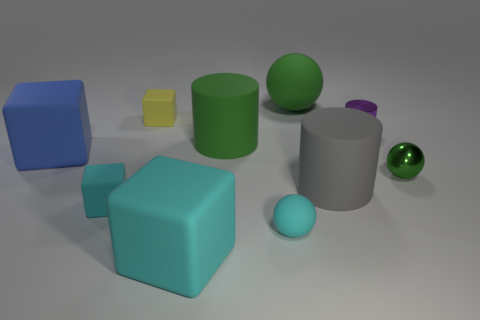Are there more cubes that are right of the big blue cube than large blue cubes that are behind the small yellow rubber thing?
Your response must be concise. Yes. There is a big object that is behind the small shiny cylinder; is it the same color as the big rubber cylinder behind the big gray rubber cylinder?
Keep it short and to the point. Yes. What is the size of the ball in front of the green sphere to the right of the large green matte object behind the tiny purple object?
Give a very brief answer. Small. What is the color of the shiny thing that is the same shape as the gray matte thing?
Offer a terse response. Purple. Is the number of green metal balls that are behind the cyan rubber ball greater than the number of purple rubber cylinders?
Give a very brief answer. Yes. Does the blue object have the same shape as the tiny matte object behind the blue rubber thing?
Ensure brevity in your answer.  Yes. What size is the purple thing that is the same shape as the gray thing?
Your answer should be compact. Small. Is the number of small purple cylinders greater than the number of large cyan cylinders?
Your response must be concise. Yes. Is the tiny yellow object the same shape as the large blue thing?
Keep it short and to the point. Yes. What is the material of the thing in front of the rubber ball that is in front of the large gray cylinder?
Provide a short and direct response. Rubber. 